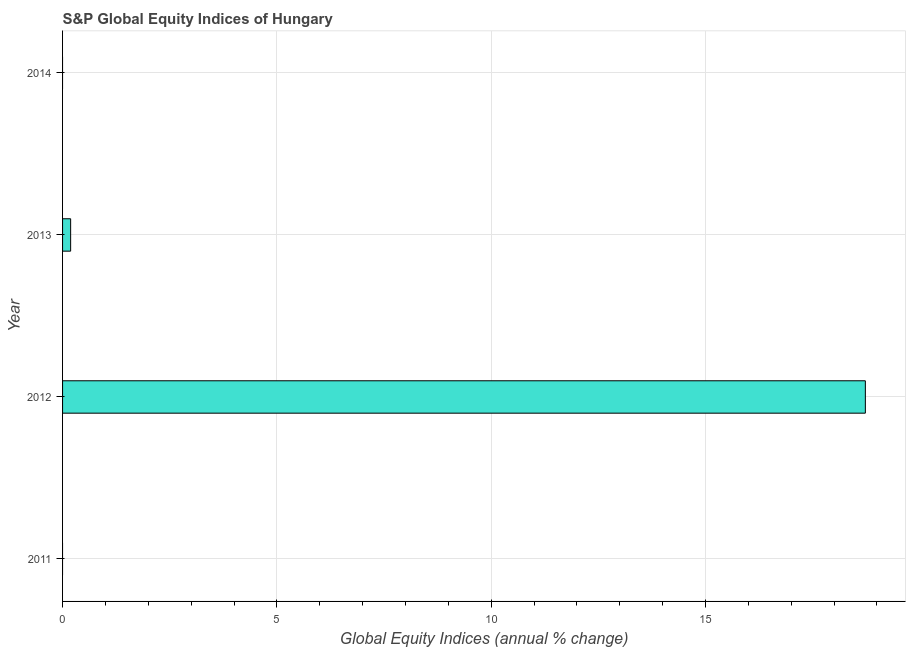Does the graph contain any zero values?
Provide a succinct answer. Yes. What is the title of the graph?
Ensure brevity in your answer.  S&P Global Equity Indices of Hungary. What is the label or title of the X-axis?
Your answer should be compact. Global Equity Indices (annual % change). What is the label or title of the Y-axis?
Offer a terse response. Year. What is the s&p global equity indices in 2014?
Offer a very short reply. 0. Across all years, what is the maximum s&p global equity indices?
Offer a terse response. 18.73. What is the sum of the s&p global equity indices?
Your answer should be very brief. 18.92. What is the difference between the s&p global equity indices in 2012 and 2013?
Ensure brevity in your answer.  18.54. What is the average s&p global equity indices per year?
Ensure brevity in your answer.  4.73. What is the median s&p global equity indices?
Your response must be concise. 0.09. In how many years, is the s&p global equity indices greater than 4 %?
Give a very brief answer. 1. What is the ratio of the s&p global equity indices in 2012 to that in 2013?
Your answer should be compact. 99.51. What is the difference between the highest and the lowest s&p global equity indices?
Your response must be concise. 18.73. In how many years, is the s&p global equity indices greater than the average s&p global equity indices taken over all years?
Your answer should be compact. 1. How many bars are there?
Offer a terse response. 2. Are all the bars in the graph horizontal?
Give a very brief answer. Yes. Are the values on the major ticks of X-axis written in scientific E-notation?
Keep it short and to the point. No. What is the Global Equity Indices (annual % change) in 2012?
Your response must be concise. 18.73. What is the Global Equity Indices (annual % change) in 2013?
Ensure brevity in your answer.  0.19. What is the difference between the Global Equity Indices (annual % change) in 2012 and 2013?
Your response must be concise. 18.54. What is the ratio of the Global Equity Indices (annual % change) in 2012 to that in 2013?
Give a very brief answer. 99.51. 